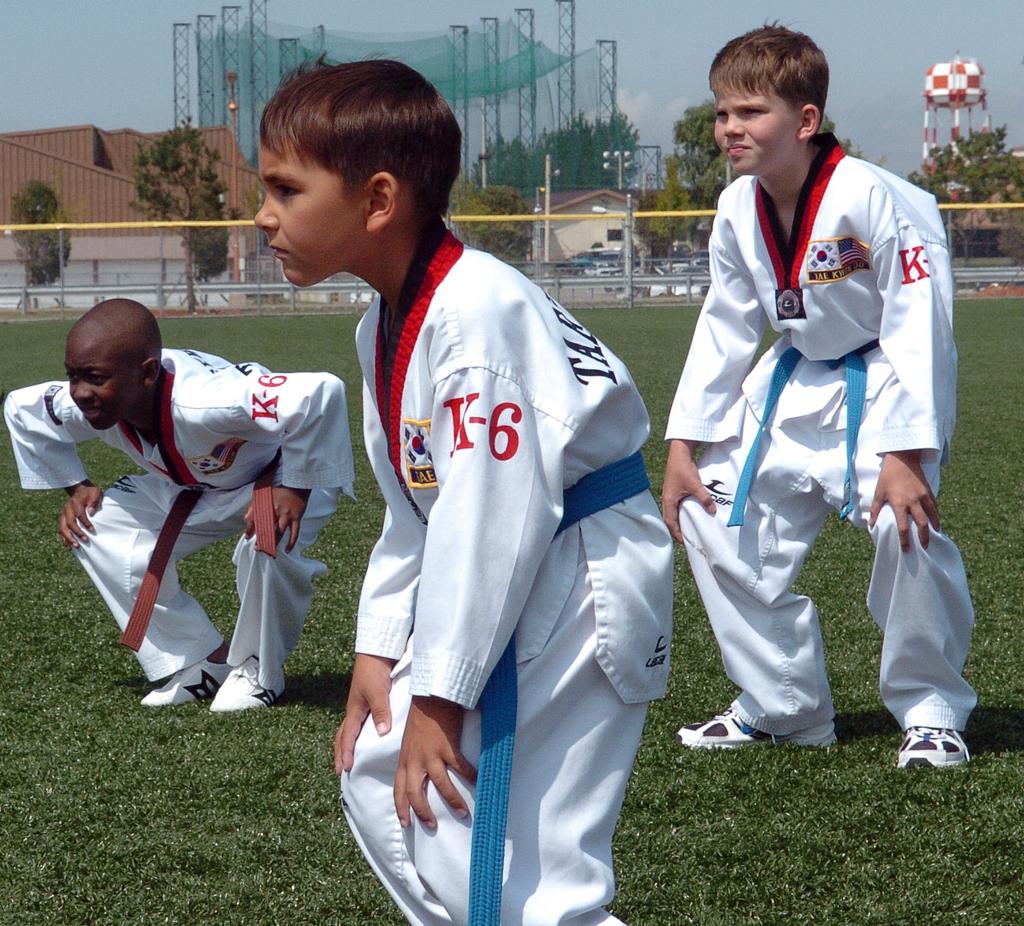Are they k-6?
Give a very brief answer. Yes. What are the visible letters on the childs shirt?
Give a very brief answer. K-6. 